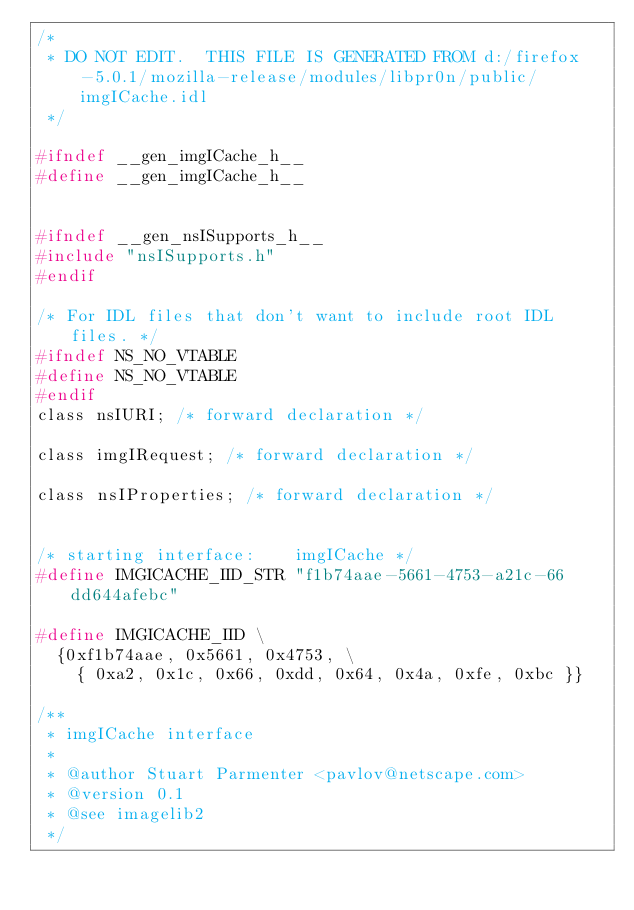Convert code to text. <code><loc_0><loc_0><loc_500><loc_500><_C_>/*
 * DO NOT EDIT.  THIS FILE IS GENERATED FROM d:/firefox-5.0.1/mozilla-release/modules/libpr0n/public/imgICache.idl
 */

#ifndef __gen_imgICache_h__
#define __gen_imgICache_h__


#ifndef __gen_nsISupports_h__
#include "nsISupports.h"
#endif

/* For IDL files that don't want to include root IDL files. */
#ifndef NS_NO_VTABLE
#define NS_NO_VTABLE
#endif
class nsIURI; /* forward declaration */

class imgIRequest; /* forward declaration */

class nsIProperties; /* forward declaration */


/* starting interface:    imgICache */
#define IMGICACHE_IID_STR "f1b74aae-5661-4753-a21c-66dd644afebc"

#define IMGICACHE_IID \
  {0xf1b74aae, 0x5661, 0x4753, \
    { 0xa2, 0x1c, 0x66, 0xdd, 0x64, 0x4a, 0xfe, 0xbc }}

/**
 * imgICache interface
 *
 * @author Stuart Parmenter <pavlov@netscape.com>
 * @version 0.1
 * @see imagelib2
 */</code> 